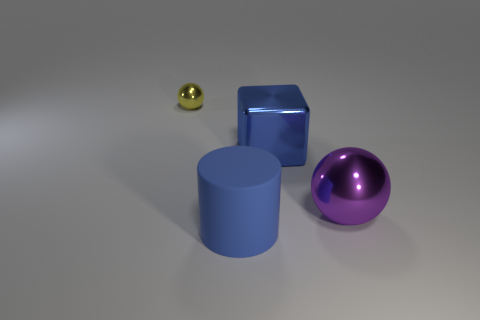Add 2 blue things. How many objects exist? 6 Subtract all cylinders. How many objects are left? 3 Add 3 blue shiny things. How many blue shiny things are left? 4 Add 2 large cylinders. How many large cylinders exist? 3 Subtract 0 yellow cylinders. How many objects are left? 4 Subtract all tiny yellow shiny things. Subtract all tiny yellow balls. How many objects are left? 2 